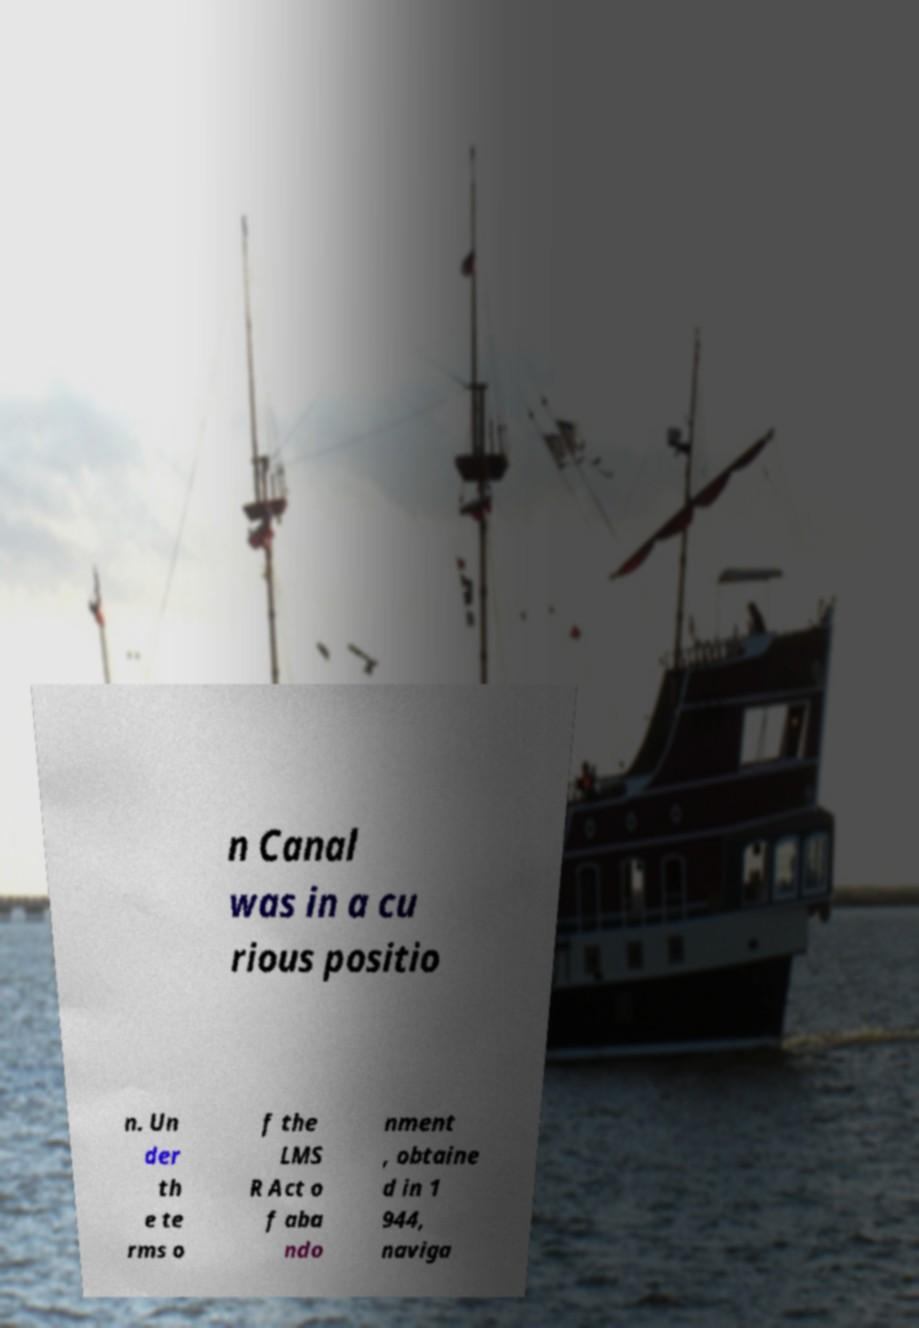I need the written content from this picture converted into text. Can you do that? n Canal was in a cu rious positio n. Un der th e te rms o f the LMS R Act o f aba ndo nment , obtaine d in 1 944, naviga 